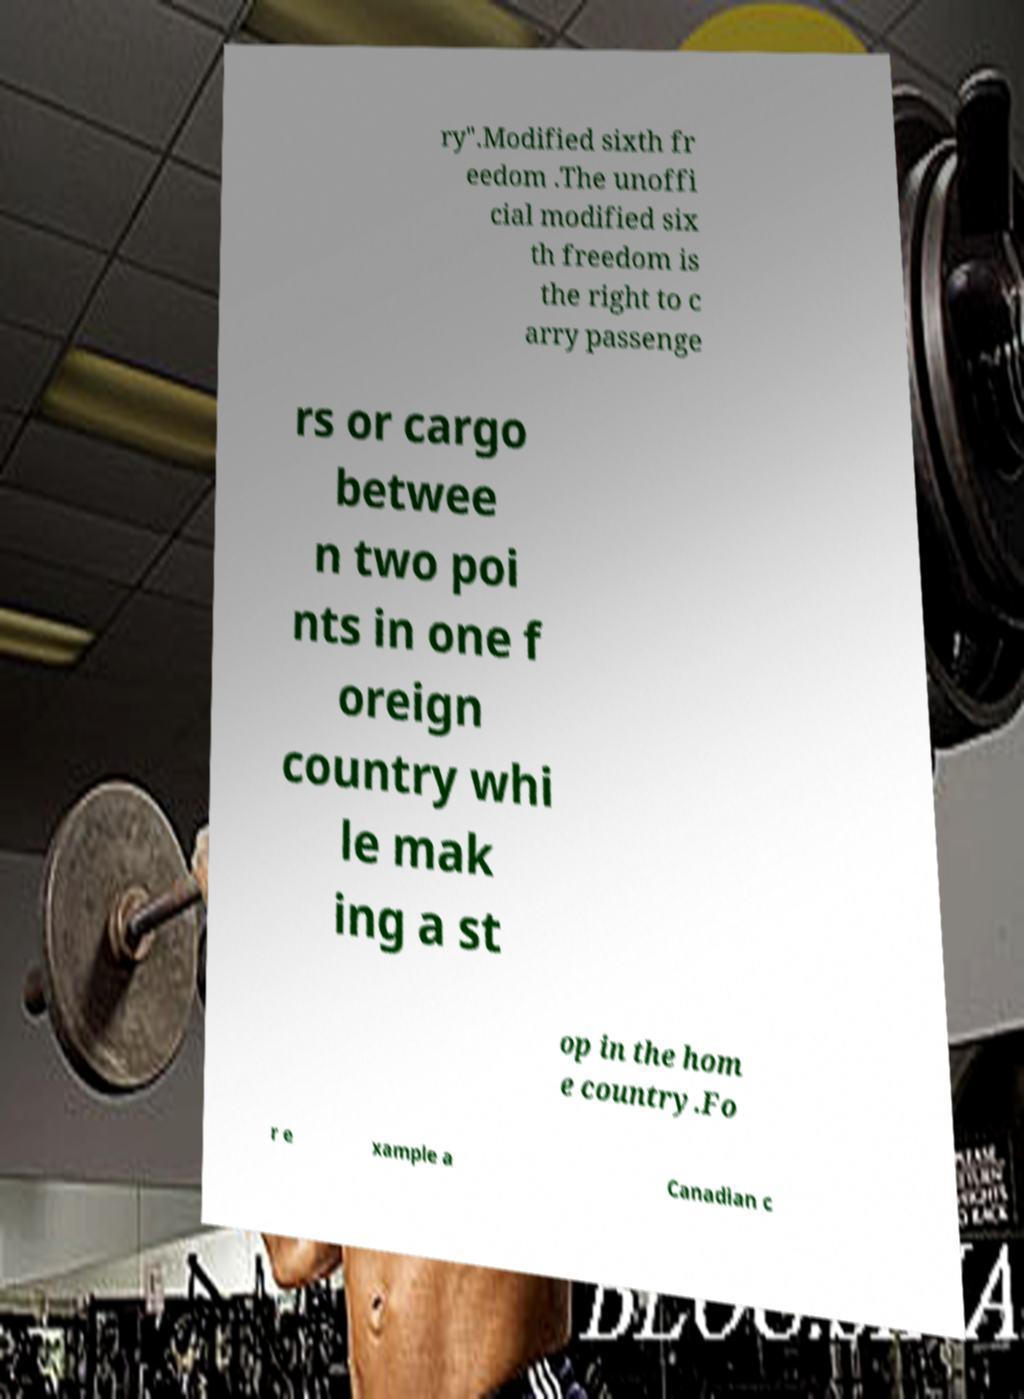I need the written content from this picture converted into text. Can you do that? ry".Modified sixth fr eedom .The unoffi cial modified six th freedom is the right to c arry passenge rs or cargo betwee n two poi nts in one f oreign country whi le mak ing a st op in the hom e country.Fo r e xample a Canadian c 